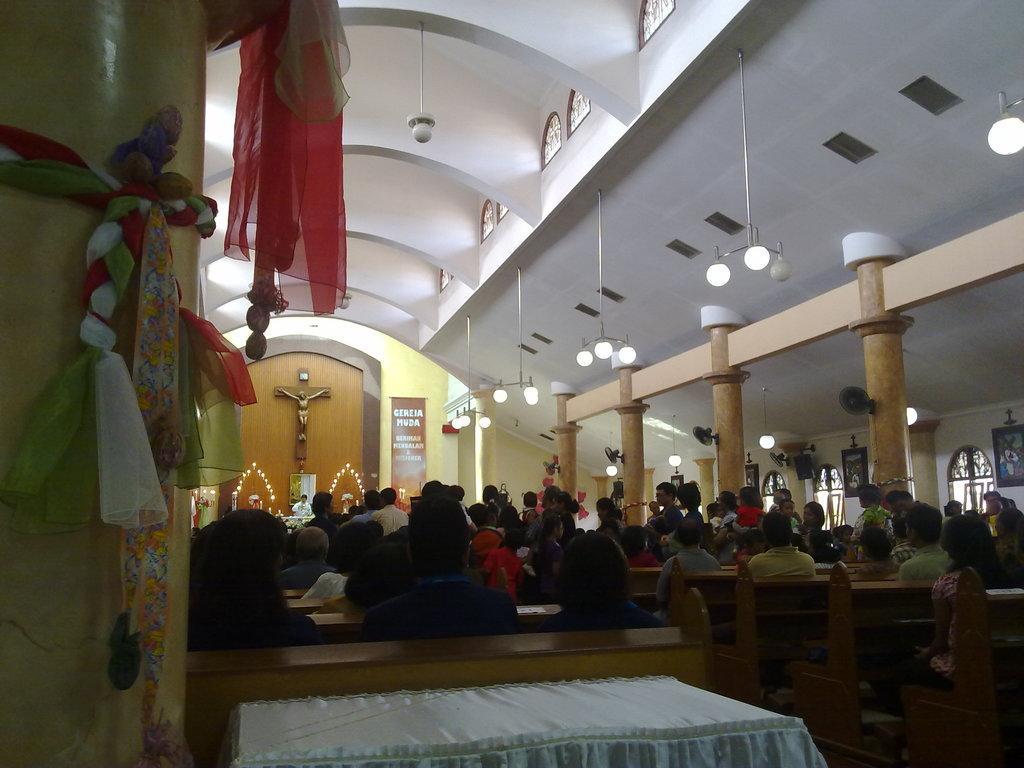Could you give a brief overview of what you see in this image? In this image, we can see people, pillars, walls, frames, lights, decorative objects, table fans, banner and few things. Here we can see few people are sitting on the benches. 